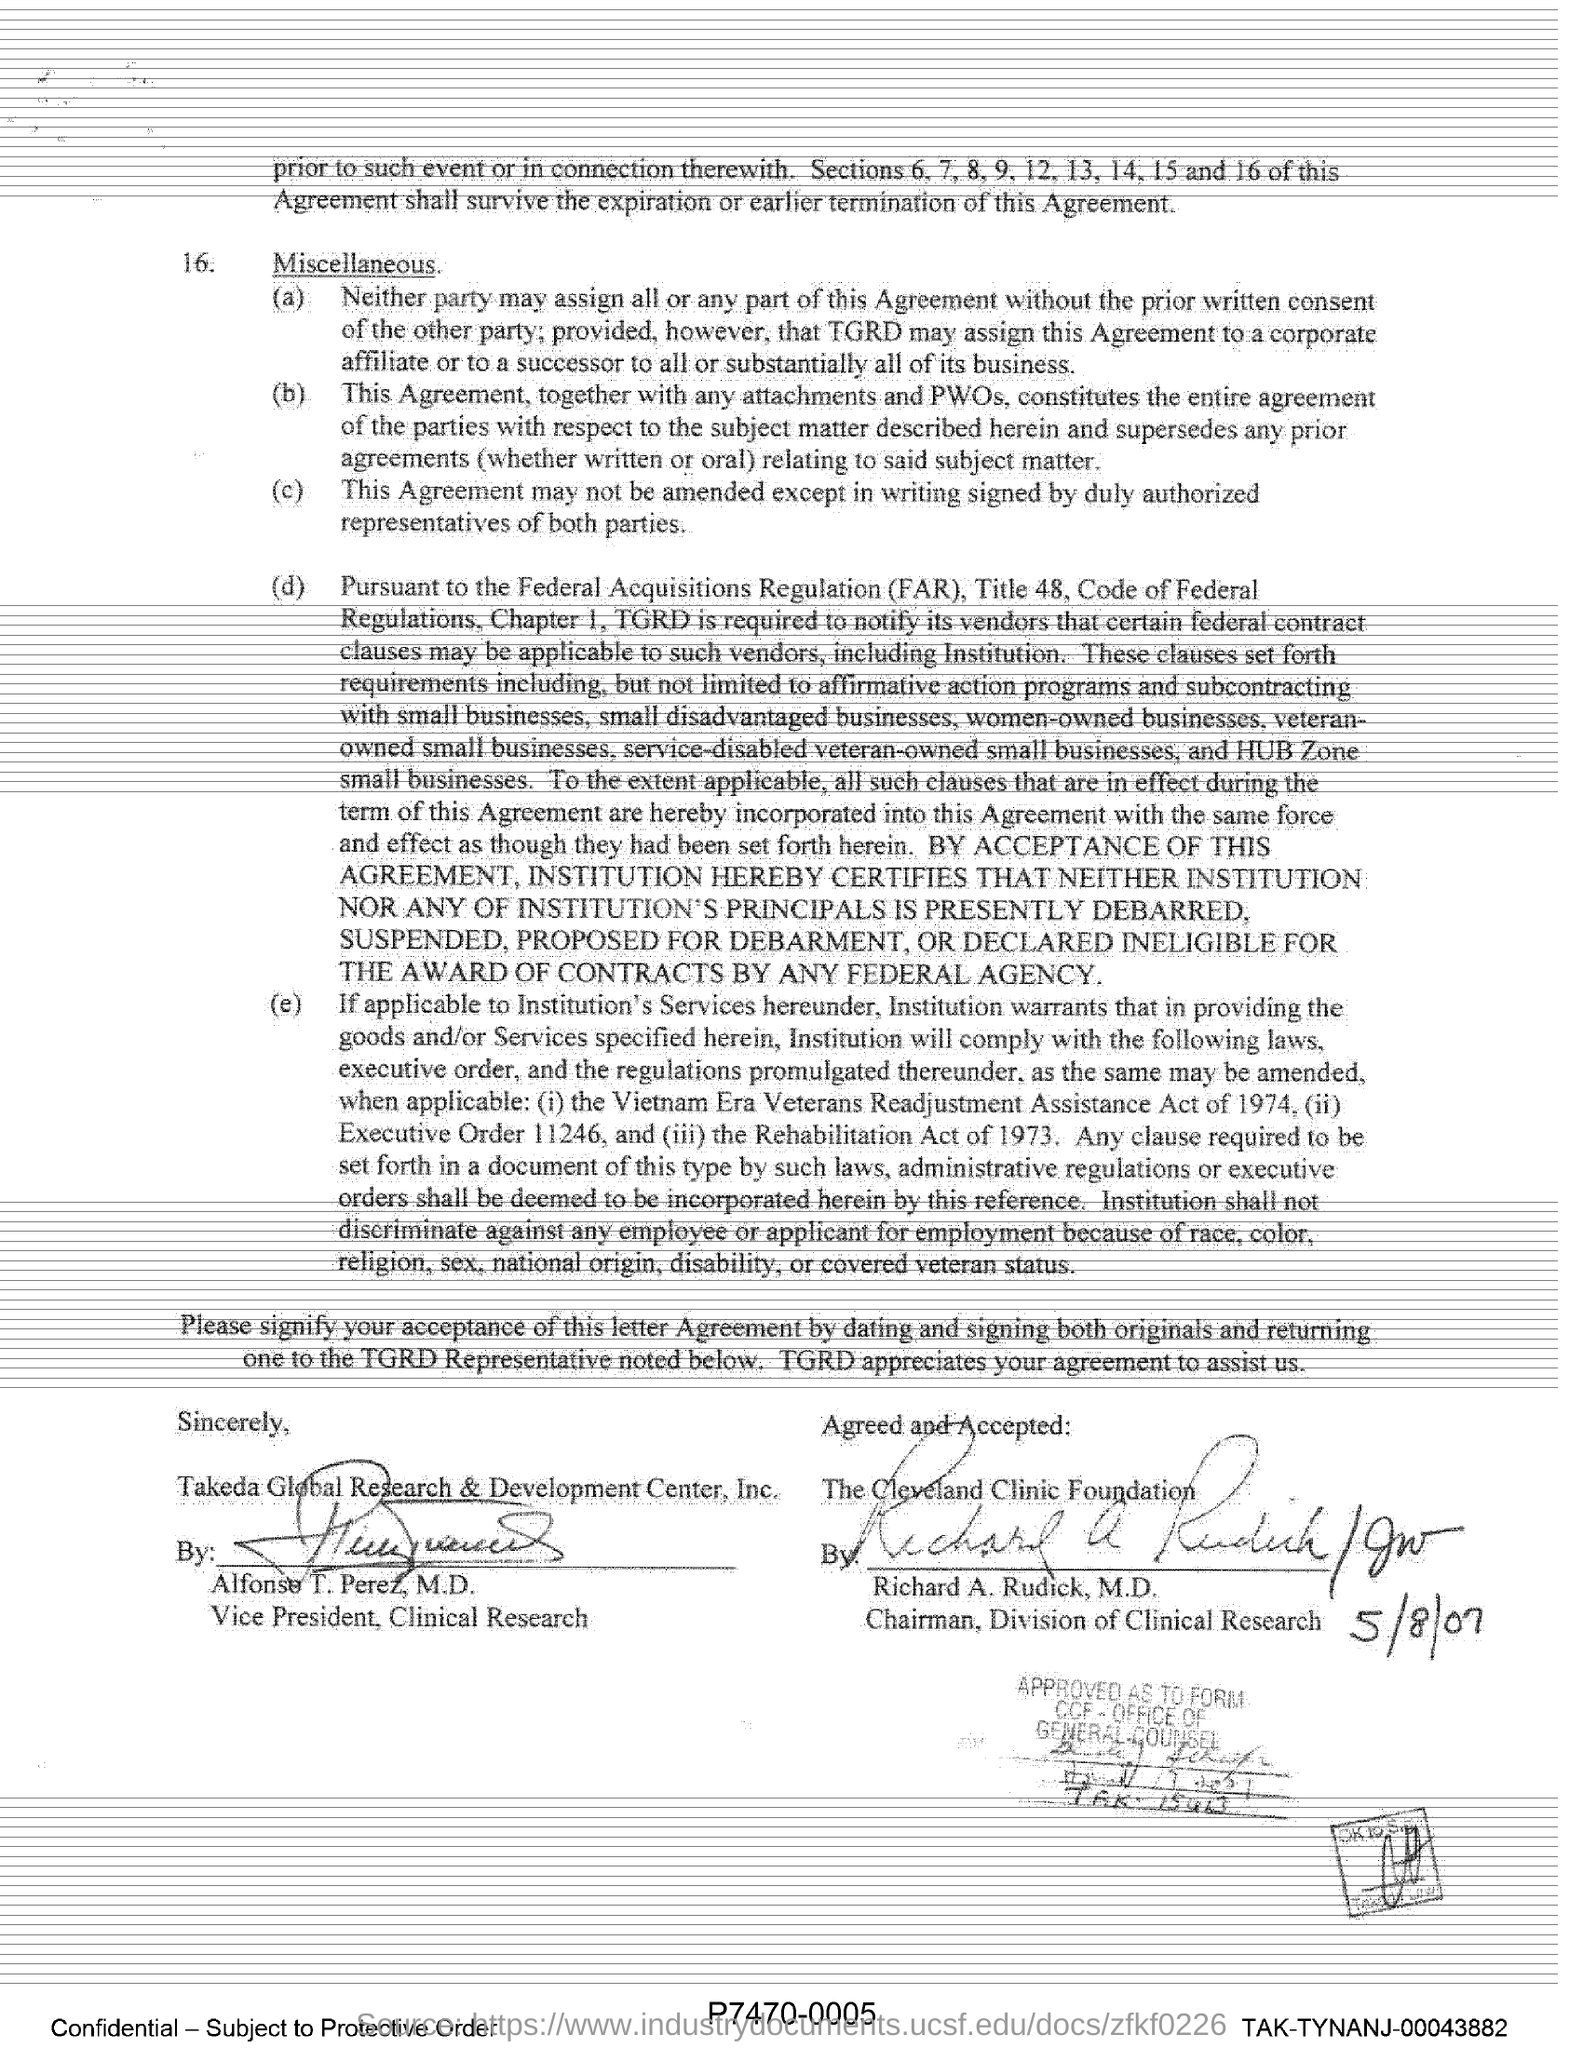What is the designation of Alfonso T. Perez, M.D.?
Offer a terse response. Vice President, Clinical Research. By whom was this agreement Agreed and Accepted?
Your answer should be very brief. Richard A. Rudick, M.D. What is the full form of FAR?
Give a very brief answer. Federal Acquisitions Regulation. What is the date of the signature of the chairman of the Division of clinical research?
Give a very brief answer. 5/8/07. 